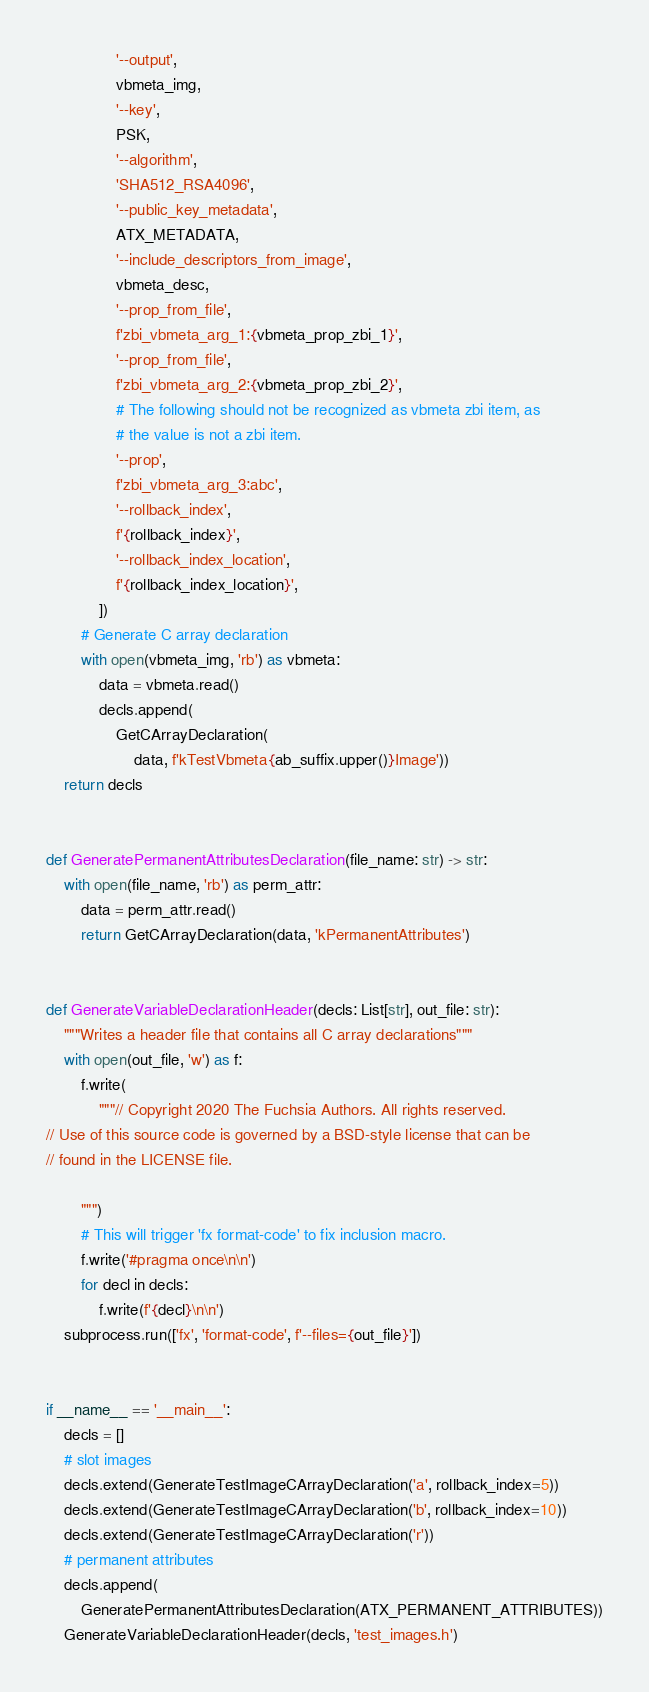<code> <loc_0><loc_0><loc_500><loc_500><_Python_>                '--output',
                vbmeta_img,
                '--key',
                PSK,
                '--algorithm',
                'SHA512_RSA4096',
                '--public_key_metadata',
                ATX_METADATA,
                '--include_descriptors_from_image',
                vbmeta_desc,
                '--prop_from_file',
                f'zbi_vbmeta_arg_1:{vbmeta_prop_zbi_1}',
                '--prop_from_file',
                f'zbi_vbmeta_arg_2:{vbmeta_prop_zbi_2}',
                # The following should not be recognized as vbmeta zbi item, as
                # the value is not a zbi item.
                '--prop',
                f'zbi_vbmeta_arg_3:abc',
                '--rollback_index',
                f'{rollback_index}',
                '--rollback_index_location',
                f'{rollback_index_location}',
            ])
        # Generate C array declaration
        with open(vbmeta_img, 'rb') as vbmeta:
            data = vbmeta.read()
            decls.append(
                GetCArrayDeclaration(
                    data, f'kTestVbmeta{ab_suffix.upper()}Image'))
    return decls


def GeneratePermanentAttributesDeclaration(file_name: str) -> str:
    with open(file_name, 'rb') as perm_attr:
        data = perm_attr.read()
        return GetCArrayDeclaration(data, 'kPermanentAttributes')


def GenerateVariableDeclarationHeader(decls: List[str], out_file: str):
    """Writes a header file that contains all C array declarations"""
    with open(out_file, 'w') as f:
        f.write(
            """// Copyright 2020 The Fuchsia Authors. All rights reserved.
// Use of this source code is governed by a BSD-style license that can be
// found in the LICENSE file.

        """)
        # This will trigger 'fx format-code' to fix inclusion macro.
        f.write('#pragma once\n\n')
        for decl in decls:
            f.write(f'{decl}\n\n')
    subprocess.run(['fx', 'format-code', f'--files={out_file}'])


if __name__ == '__main__':
    decls = []
    # slot images
    decls.extend(GenerateTestImageCArrayDeclaration('a', rollback_index=5))
    decls.extend(GenerateTestImageCArrayDeclaration('b', rollback_index=10))
    decls.extend(GenerateTestImageCArrayDeclaration('r'))
    # permanent attributes
    decls.append(
        GeneratePermanentAttributesDeclaration(ATX_PERMANENT_ATTRIBUTES))
    GenerateVariableDeclarationHeader(decls, 'test_images.h')
</code> 